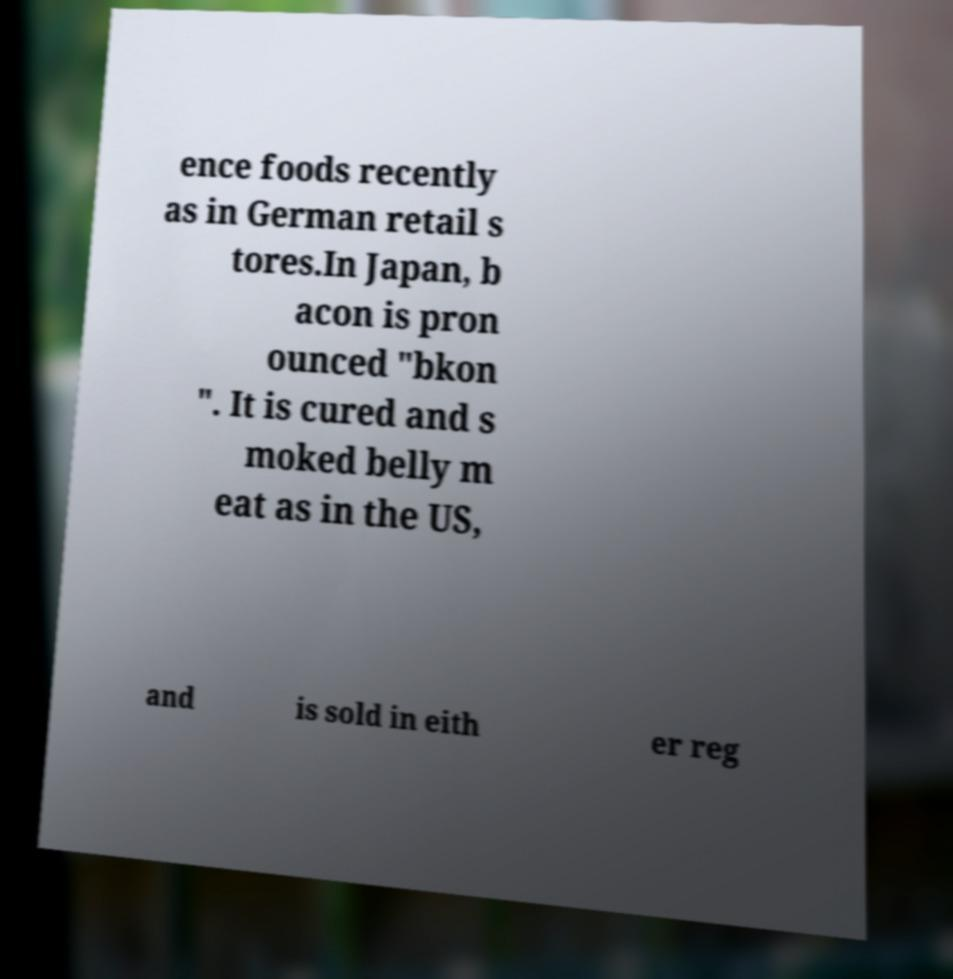For documentation purposes, I need the text within this image transcribed. Could you provide that? ence foods recently as in German retail s tores.In Japan, b acon is pron ounced "bkon ". It is cured and s moked belly m eat as in the US, and is sold in eith er reg 